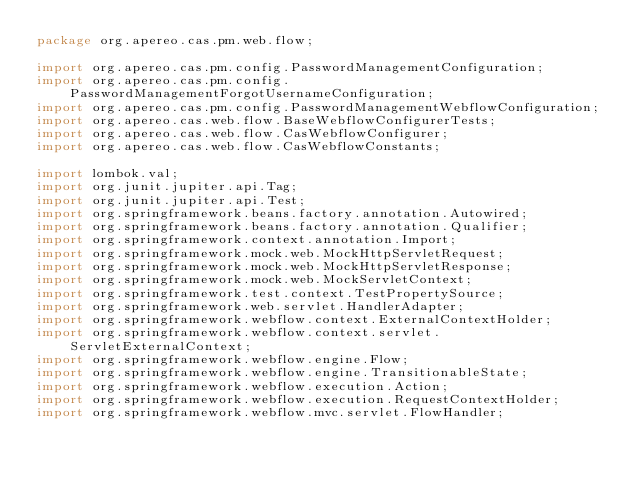Convert code to text. <code><loc_0><loc_0><loc_500><loc_500><_Java_>package org.apereo.cas.pm.web.flow;

import org.apereo.cas.pm.config.PasswordManagementConfiguration;
import org.apereo.cas.pm.config.PasswordManagementForgotUsernameConfiguration;
import org.apereo.cas.pm.config.PasswordManagementWebflowConfiguration;
import org.apereo.cas.web.flow.BaseWebflowConfigurerTests;
import org.apereo.cas.web.flow.CasWebflowConfigurer;
import org.apereo.cas.web.flow.CasWebflowConstants;

import lombok.val;
import org.junit.jupiter.api.Tag;
import org.junit.jupiter.api.Test;
import org.springframework.beans.factory.annotation.Autowired;
import org.springframework.beans.factory.annotation.Qualifier;
import org.springframework.context.annotation.Import;
import org.springframework.mock.web.MockHttpServletRequest;
import org.springframework.mock.web.MockHttpServletResponse;
import org.springframework.mock.web.MockServletContext;
import org.springframework.test.context.TestPropertySource;
import org.springframework.web.servlet.HandlerAdapter;
import org.springframework.webflow.context.ExternalContextHolder;
import org.springframework.webflow.context.servlet.ServletExternalContext;
import org.springframework.webflow.engine.Flow;
import org.springframework.webflow.engine.TransitionableState;
import org.springframework.webflow.execution.Action;
import org.springframework.webflow.execution.RequestContextHolder;
import org.springframework.webflow.mvc.servlet.FlowHandler;</code> 